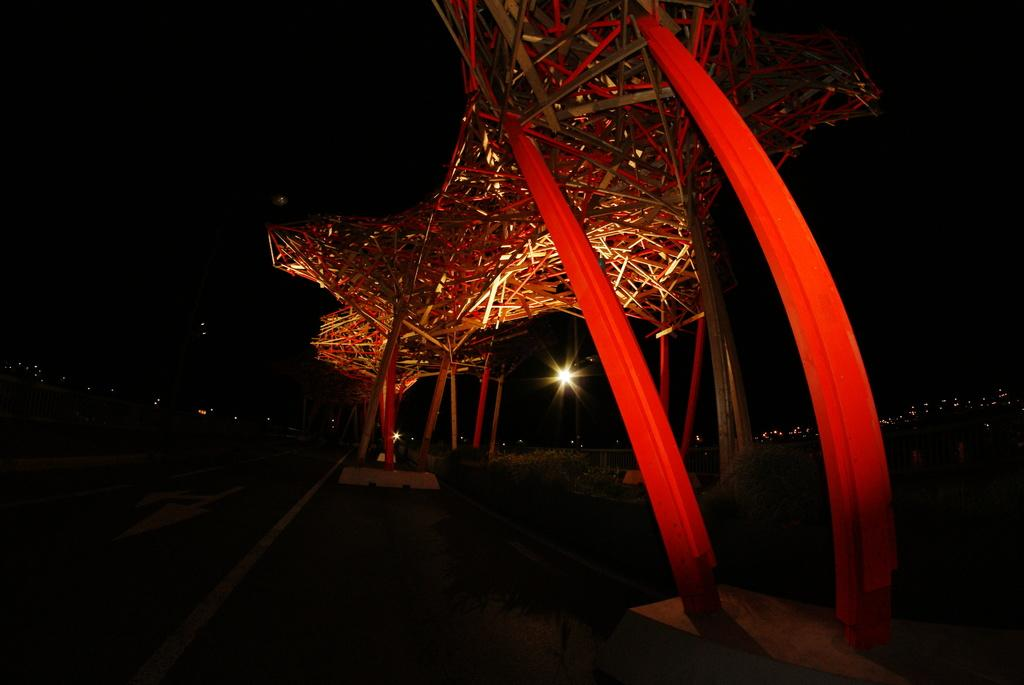What is the main structure in the center of the image? There is a bridge in the center of the image. What is located at the bottom of the image? There is a road at the bottom of the image. Can you describe any features of the road? There is a light on the road. What can be seen in the background of the image? There are buildings in the background of the image. What type of ice can be seen melting on the bridge in the image? There is no ice present in the image, and therefore no ice can be seen melting on the bridge. 